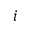<formula> <loc_0><loc_0><loc_500><loc_500>i</formula> 